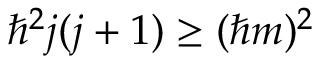<formula> <loc_0><loc_0><loc_500><loc_500>\hbar { ^ } { 2 } j ( j + 1 ) \geq ( \hbar { m } ) ^ { 2 }</formula> 